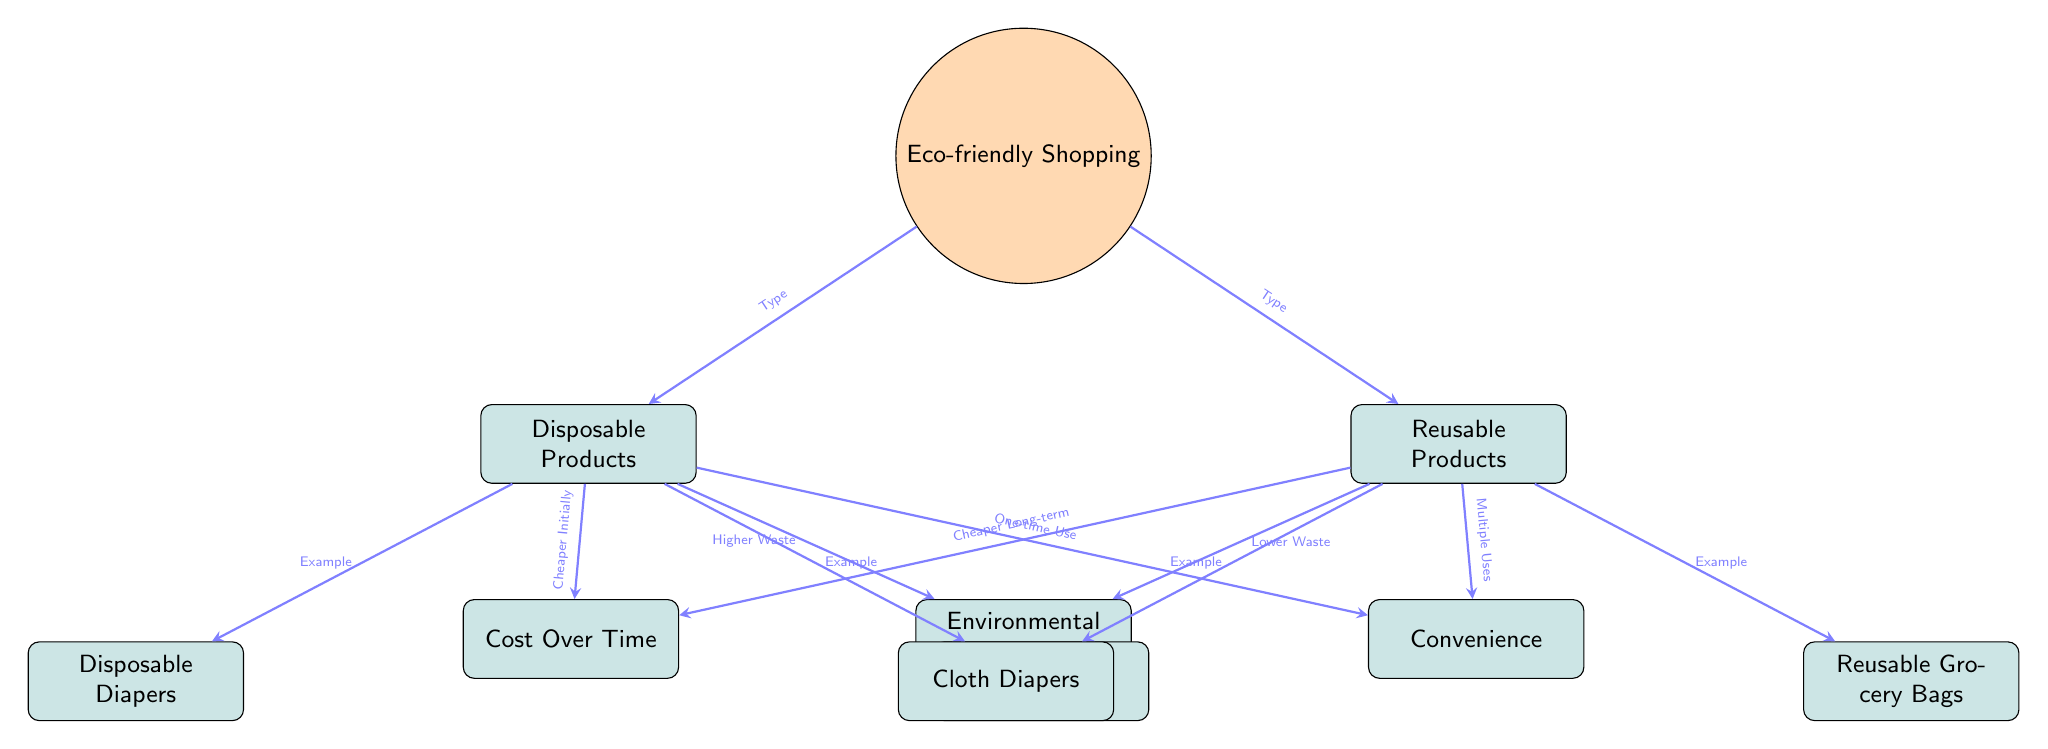What is the main focus of the diagram? The diagram centers around "Eco-friendly Shopping," which is the main node at the top and serves as the focal point connecting to both disposable and reusable product categories.
Answer: Eco-friendly Shopping What types of products are compared in this diagram? The diagram illustrates two types of products: disposable products on the left and reusable products on the right, indicating the categories being compared.
Answer: Disposable Products and Reusable Products Which product category has a higher environmental impact? The arrow connecting disposable products to environmental impact indicates that disposable products are linked to "Higher Waste," showing they have a greater negative impact on the environment compared to reusable products.
Answer: Higher Waste How does the cost over time compare between disposable and reusable products? The arrow from disposable products states "Cheaper Initially," whereas the arrow from reusable products indicates "Cheaper Long-term." This information allows us to conclude that while disposable products may be cheaper upfront, reusable products save money over time.
Answer: Cheaper Long-term What are the examples of disposable products mentioned in the diagram? The diagram lists "Disposable Diapers" and "Plastic Grocery Bags" as examples of disposable products under the disposable category.
Answer: Disposable Diapers, Plastic Grocery Bags How many main product categories are depicted in the diagram? There are two main categories depicted: Disposable Products and Reusable Products, which are the primary focus areas of the comparison.
Answer: 2 Which category offers convenience through multiple uses? The arrow leading from reusable products to the convenience node states "Multiple Uses," indicating that reusable products provide more convenience in this regard compared to their disposable counterparts.
Answer: Multiple Uses What does the arrow indicate from reusable products to the environmental impact? The arrow points from the reusable products to the environmental impact node, stating "Lower Waste," suggesting that choosing reusable options is beneficial for the environment as it results in less waste.
Answer: Lower Waste Which example of reusable product is included in the diagram? Under the reusable products category, "Cloth Diapers" and "Reusable Grocery Bags" are provided as specific examples of reusable products used in eco-friendly shopping.
Answer: Cloth Diapers, Reusable Grocery Bags 